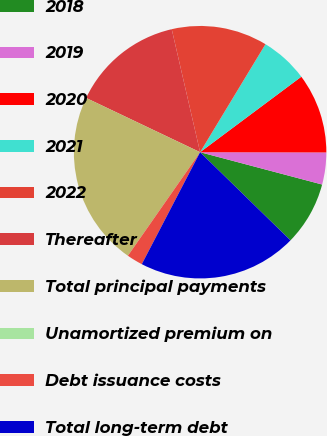Convert chart. <chart><loc_0><loc_0><loc_500><loc_500><pie_chart><fcel>2018<fcel>2019<fcel>2020<fcel>2021<fcel>2022<fcel>Thereafter<fcel>Total principal payments<fcel>Unamortized premium on<fcel>Debt issuance costs<fcel>Total long-term debt<nl><fcel>8.18%<fcel>4.09%<fcel>10.23%<fcel>6.14%<fcel>12.27%<fcel>14.32%<fcel>22.38%<fcel>0.0%<fcel>2.05%<fcel>20.34%<nl></chart> 